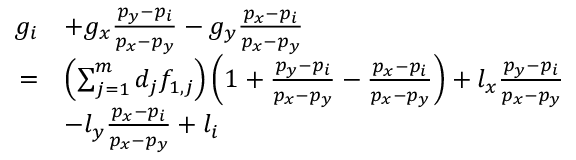<formula> <loc_0><loc_0><loc_500><loc_500>\begin{array} { r l } { g _ { i } } & { + g _ { x } \frac { p _ { y } - p _ { i } } { p _ { x } - p _ { y } } - g _ { y } \frac { p _ { x } - p _ { i } } { p _ { x } - p _ { y } } } \\ { = } & { \left ( \sum _ { j = 1 } ^ { m } { d } _ { j } f _ { 1 , j } \right ) \left ( 1 + \frac { p _ { y } - p _ { i } } { p _ { x } - p _ { y } } - \frac { p _ { x } - p _ { i } } { p _ { x } - p _ { y } } \right ) + l _ { x } \frac { p _ { y } - p _ { i } } { p _ { x } - p _ { y } } } \\ & { - l _ { y } \frac { p _ { x } - p _ { i } } { p _ { x } - p _ { y } } + l _ { i } } \end{array}</formula> 